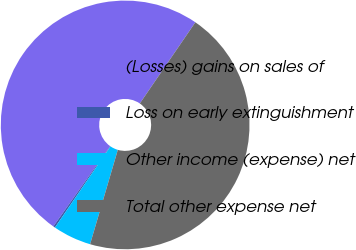Convert chart. <chart><loc_0><loc_0><loc_500><loc_500><pie_chart><fcel>(Losses) gains on sales of<fcel>Loss on early extinguishment<fcel>Other income (expense) net<fcel>Total other expense net<nl><fcel>49.75%<fcel>0.25%<fcel>5.0%<fcel>45.0%<nl></chart> 